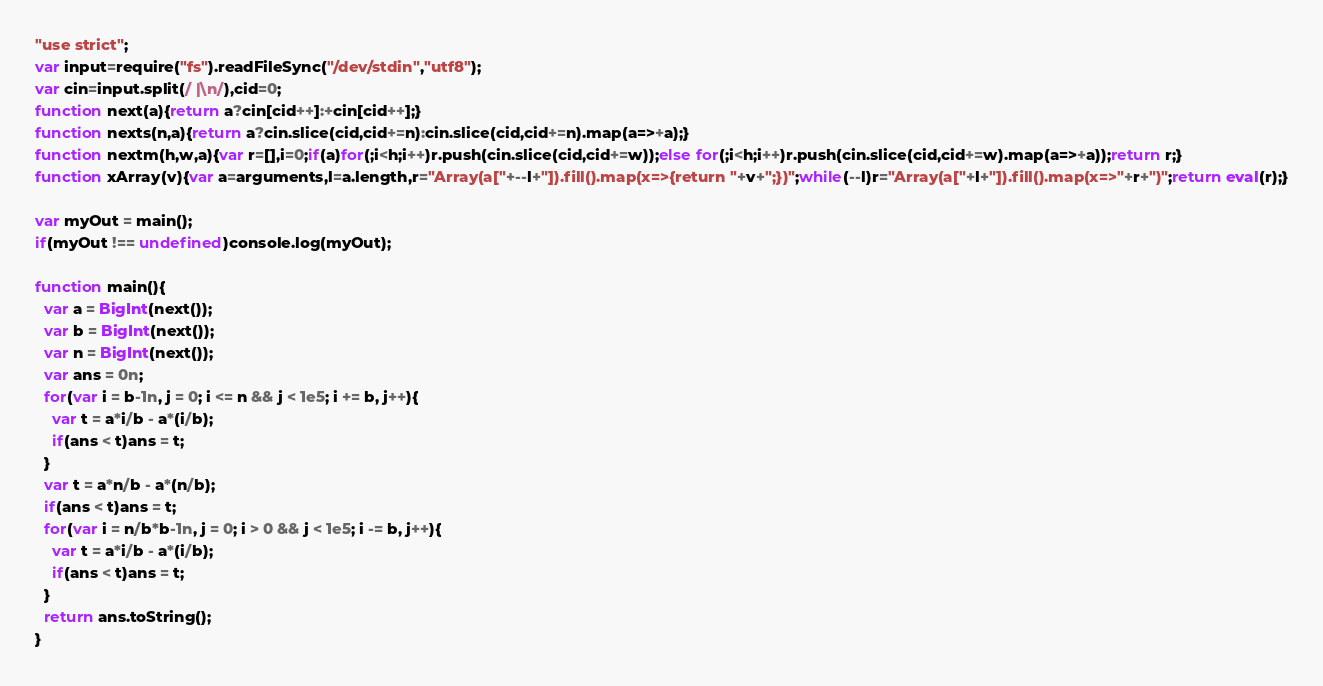<code> <loc_0><loc_0><loc_500><loc_500><_JavaScript_>"use strict";
var input=require("fs").readFileSync("/dev/stdin","utf8");
var cin=input.split(/ |\n/),cid=0;
function next(a){return a?cin[cid++]:+cin[cid++];}
function nexts(n,a){return a?cin.slice(cid,cid+=n):cin.slice(cid,cid+=n).map(a=>+a);}
function nextm(h,w,a){var r=[],i=0;if(a)for(;i<h;i++)r.push(cin.slice(cid,cid+=w));else for(;i<h;i++)r.push(cin.slice(cid,cid+=w).map(a=>+a));return r;}
function xArray(v){var a=arguments,l=a.length,r="Array(a["+--l+"]).fill().map(x=>{return "+v+";})";while(--l)r="Array(a["+l+"]).fill().map(x=>"+r+")";return eval(r);}

var myOut = main();
if(myOut !== undefined)console.log(myOut);

function main(){
  var a = BigInt(next());
  var b = BigInt(next());
  var n = BigInt(next());
  var ans = 0n;
  for(var i = b-1n, j = 0; i <= n && j < 1e5; i += b, j++){
    var t = a*i/b - a*(i/b);
    if(ans < t)ans = t;
  }
  var t = a*n/b - a*(n/b);
  if(ans < t)ans = t;
  for(var i = n/b*b-1n, j = 0; i > 0 && j < 1e5; i -= b, j++){
    var t = a*i/b - a*(i/b);
    if(ans < t)ans = t;
  }
  return ans.toString();
}</code> 